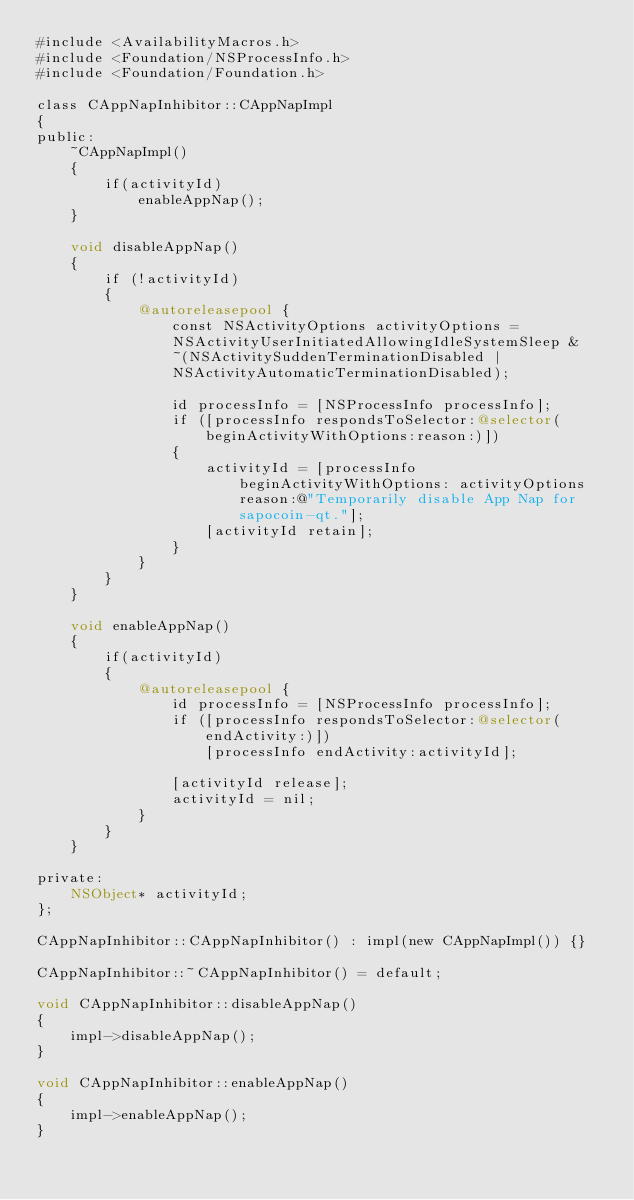Convert code to text. <code><loc_0><loc_0><loc_500><loc_500><_ObjectiveC_>#include <AvailabilityMacros.h>
#include <Foundation/NSProcessInfo.h>
#include <Foundation/Foundation.h>

class CAppNapInhibitor::CAppNapImpl
{
public:
    ~CAppNapImpl()
    {
        if(activityId)
            enableAppNap();
    }

    void disableAppNap()
    {
        if (!activityId)
        {
            @autoreleasepool {
                const NSActivityOptions activityOptions =
                NSActivityUserInitiatedAllowingIdleSystemSleep &
                ~(NSActivitySuddenTerminationDisabled |
                NSActivityAutomaticTerminationDisabled);

                id processInfo = [NSProcessInfo processInfo];
                if ([processInfo respondsToSelector:@selector(beginActivityWithOptions:reason:)])
                {
                    activityId = [processInfo beginActivityWithOptions: activityOptions reason:@"Temporarily disable App Nap for sapocoin-qt."];
                    [activityId retain];
                }
            }
        }
    }

    void enableAppNap()
    {
        if(activityId)
        {
            @autoreleasepool {
                id processInfo = [NSProcessInfo processInfo];
                if ([processInfo respondsToSelector:@selector(endActivity:)])
                    [processInfo endActivity:activityId];

                [activityId release];
                activityId = nil;
            }
        }
    }

private:
    NSObject* activityId;
};

CAppNapInhibitor::CAppNapInhibitor() : impl(new CAppNapImpl()) {}

CAppNapInhibitor::~CAppNapInhibitor() = default;

void CAppNapInhibitor::disableAppNap()
{
    impl->disableAppNap();
}

void CAppNapInhibitor::enableAppNap()
{
    impl->enableAppNap();
}
</code> 